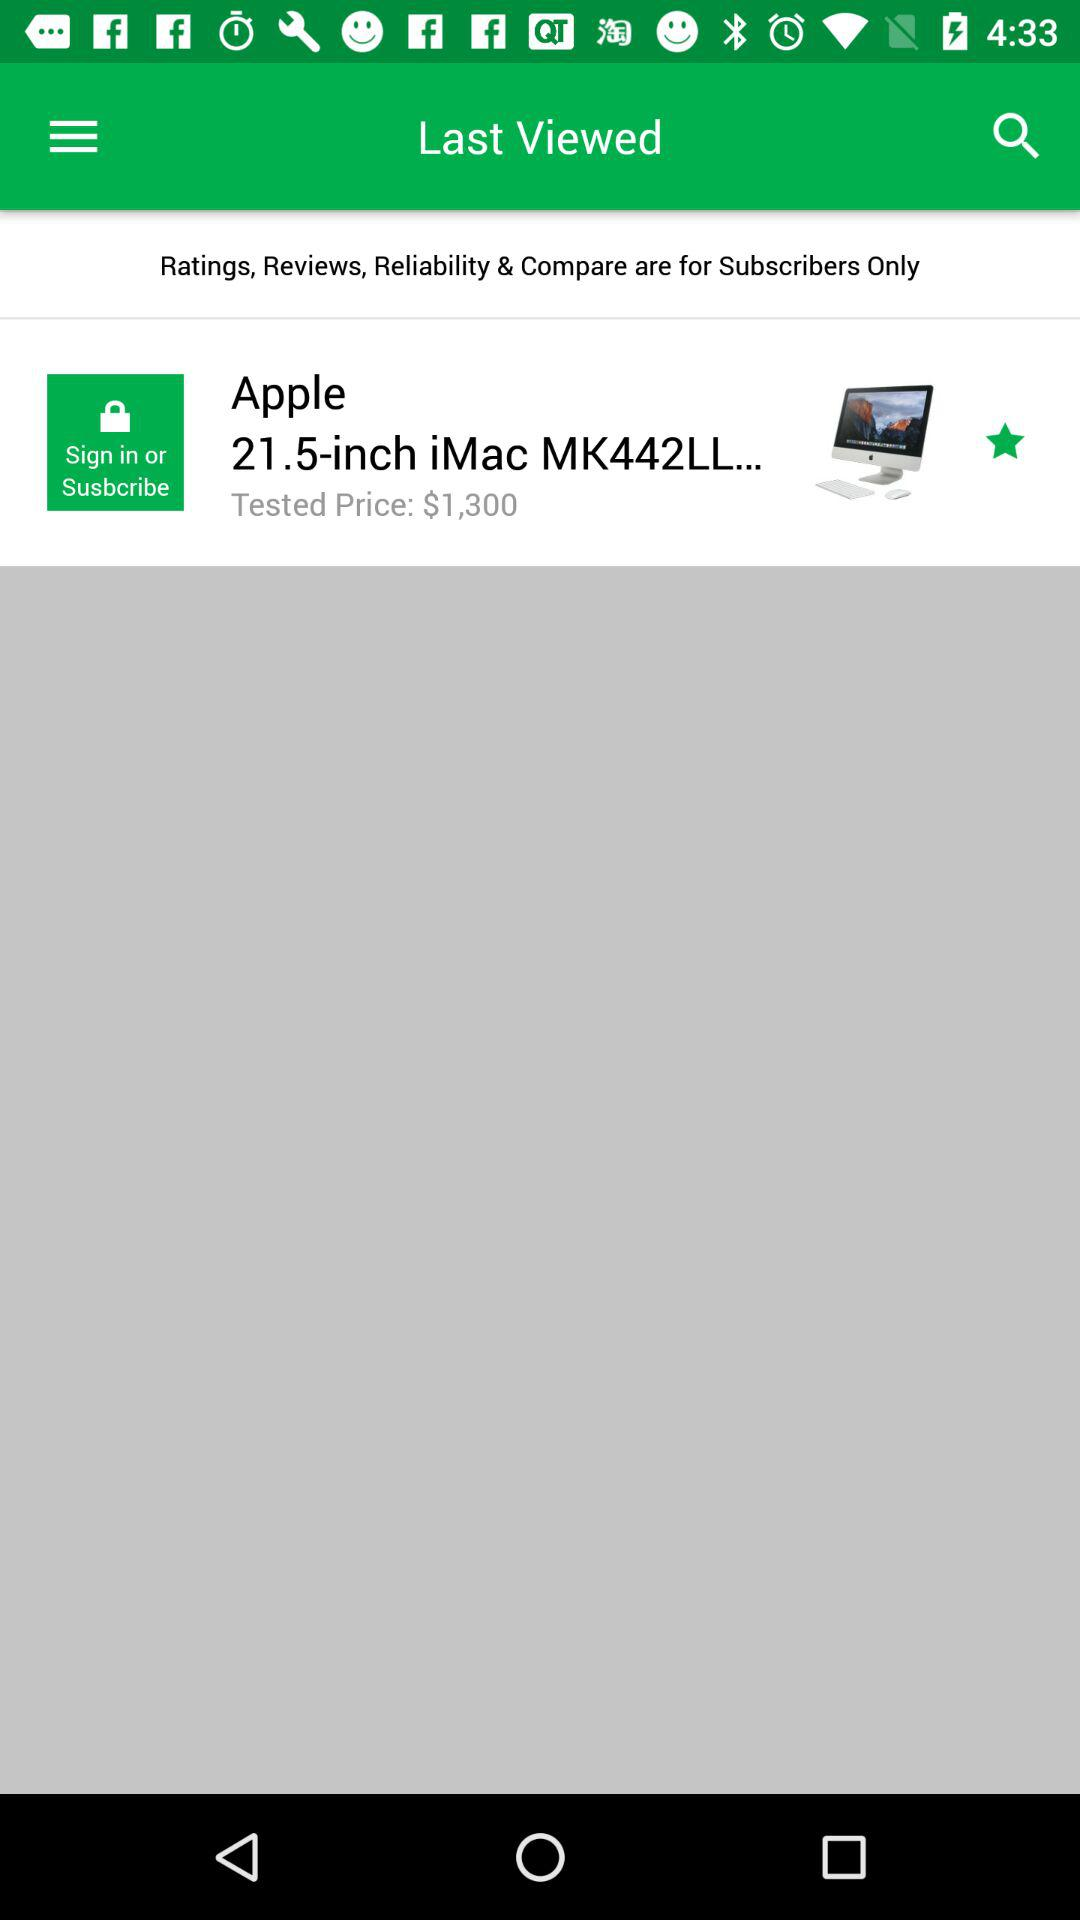What is the tested price of the product? The price of the product is $1,300. 